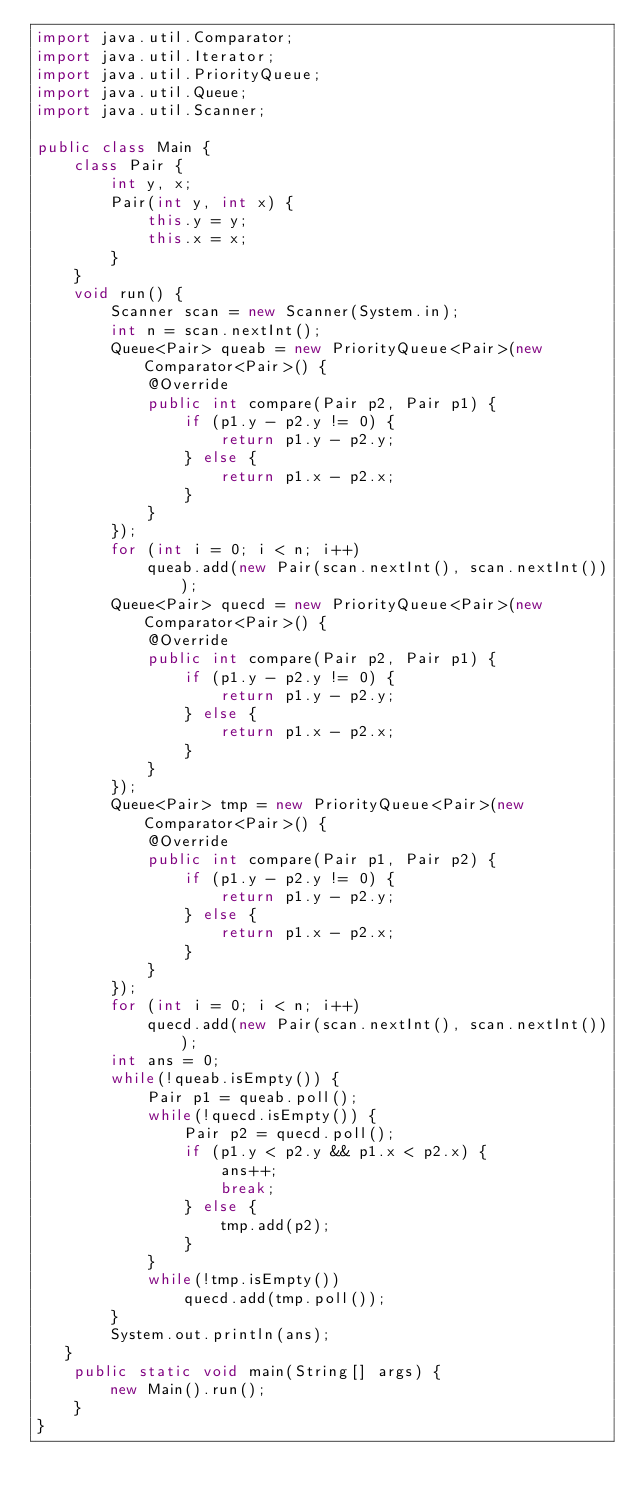Convert code to text. <code><loc_0><loc_0><loc_500><loc_500><_Java_>import java.util.Comparator;
import java.util.Iterator;
import java.util.PriorityQueue;
import java.util.Queue;
import java.util.Scanner;

public class Main {
    class Pair {
        int y, x;
        Pair(int y, int x) {
            this.y = y;
            this.x = x;
        }
    }
    void run() {
        Scanner scan = new Scanner(System.in);
        int n = scan.nextInt();
        Queue<Pair> queab = new PriorityQueue<Pair>(new Comparator<Pair>() {
            @Override
            public int compare(Pair p2, Pair p1) {
                if (p1.y - p2.y != 0) {
                    return p1.y - p2.y;
                } else {
                    return p1.x - p2.x;
                }
            }
        });
        for (int i = 0; i < n; i++)
            queab.add(new Pair(scan.nextInt(), scan.nextInt()));
        Queue<Pair> quecd = new PriorityQueue<Pair>(new Comparator<Pair>() {
            @Override
            public int compare(Pair p2, Pair p1) {
                if (p1.y - p2.y != 0) {
                    return p1.y - p2.y;
                } else {
                    return p1.x - p2.x;
                }
            }
        });
        Queue<Pair> tmp = new PriorityQueue<Pair>(new Comparator<Pair>() {
            @Override
            public int compare(Pair p1, Pair p2) {
                if (p1.y - p2.y != 0) {
                    return p1.y - p2.y;
                } else {
                    return p1.x - p2.x;
                }
            }
        });
        for (int i = 0; i < n; i++)
            quecd.add(new Pair(scan.nextInt(), scan.nextInt()));
        int ans = 0;
        while(!queab.isEmpty()) {
            Pair p1 = queab.poll();
            while(!quecd.isEmpty()) {
                Pair p2 = quecd.poll(); 
                if (p1.y < p2.y && p1.x < p2.x) {
                    ans++;
                    break;
                } else {
                    tmp.add(p2);
                }
            }
            while(!tmp.isEmpty())
                quecd.add(tmp.poll());
        }
        System.out.println(ans);
   }
    public static void main(String[] args) {
        new Main().run();
    }
}
</code> 